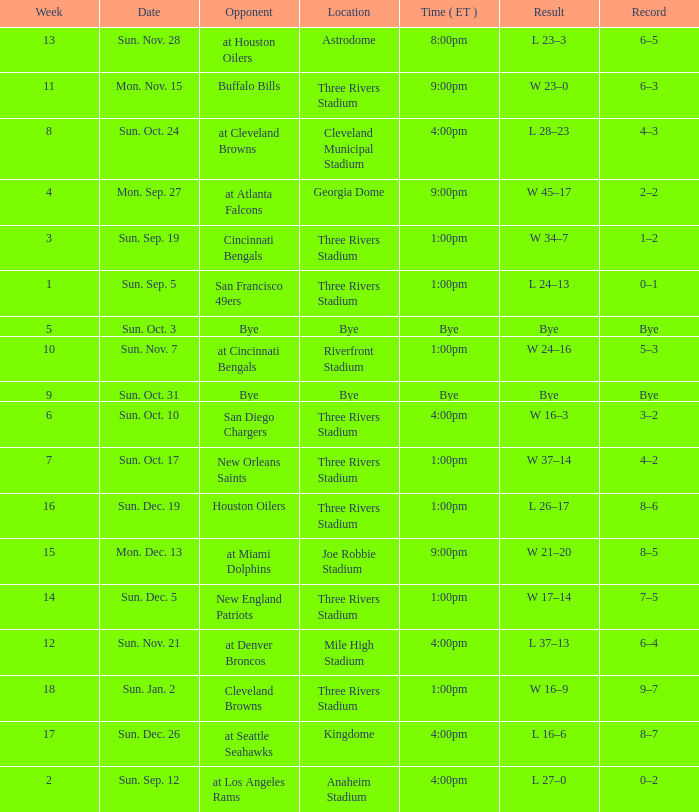What is the average Week for the game at three rivers stadium, with a Record of 3–2? 6.0. 